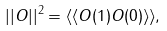<formula> <loc_0><loc_0><loc_500><loc_500>| | O | | ^ { 2 } = \langle \langle O ( 1 ) O ( 0 ) \rangle \rangle ,</formula> 